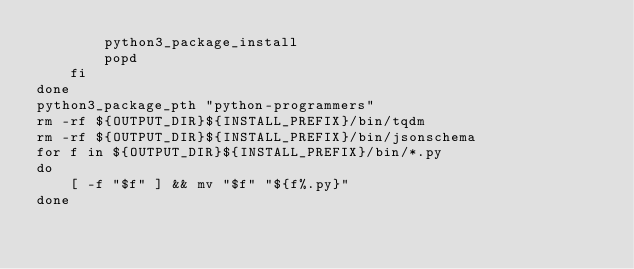<code> <loc_0><loc_0><loc_500><loc_500><_Bash_>        python3_package_install
        popd
    fi
done
python3_package_pth "python-programmers"
rm -rf ${OUTPUT_DIR}${INSTALL_PREFIX}/bin/tqdm
rm -rf ${OUTPUT_DIR}${INSTALL_PREFIX}/bin/jsonschema
for f in ${OUTPUT_DIR}${INSTALL_PREFIX}/bin/*.py
do
    [ -f "$f" ] && mv "$f" "${f%.py}"
done</code> 